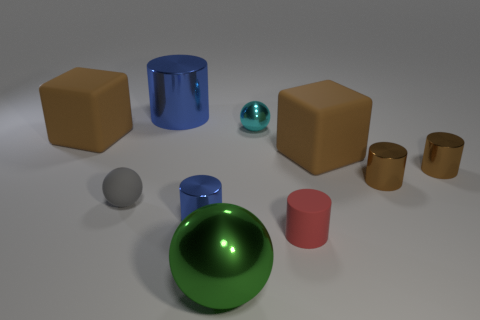Is there any other thing that has the same size as the gray object?
Make the answer very short. Yes. There is a big green thing that is the same shape as the gray rubber object; what is its material?
Provide a succinct answer. Metal. Are there more big green spheres than metallic objects?
Ensure brevity in your answer.  No. How many other things are the same color as the tiny metal sphere?
Provide a succinct answer. 0. Is the material of the green ball the same as the big cube to the right of the large shiny ball?
Make the answer very short. No. There is a blue metal cylinder in front of the tiny gray thing behind the big green ball; how many large blocks are on the left side of it?
Provide a short and direct response. 1. Are there fewer matte blocks that are left of the small gray sphere than big balls to the left of the large green ball?
Make the answer very short. No. What number of other objects are there of the same material as the big sphere?
Give a very brief answer. 5. There is a cyan thing that is the same size as the matte cylinder; what is it made of?
Ensure brevity in your answer.  Metal. What number of purple things are either small metallic objects or tiny shiny spheres?
Provide a succinct answer. 0. 